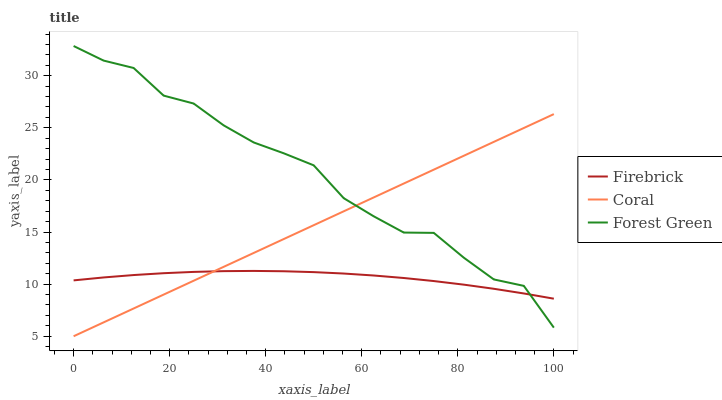Does Coral have the minimum area under the curve?
Answer yes or no. No. Does Coral have the maximum area under the curve?
Answer yes or no. No. Is Firebrick the smoothest?
Answer yes or no. No. Is Firebrick the roughest?
Answer yes or no. No. Does Firebrick have the lowest value?
Answer yes or no. No. Does Coral have the highest value?
Answer yes or no. No. 